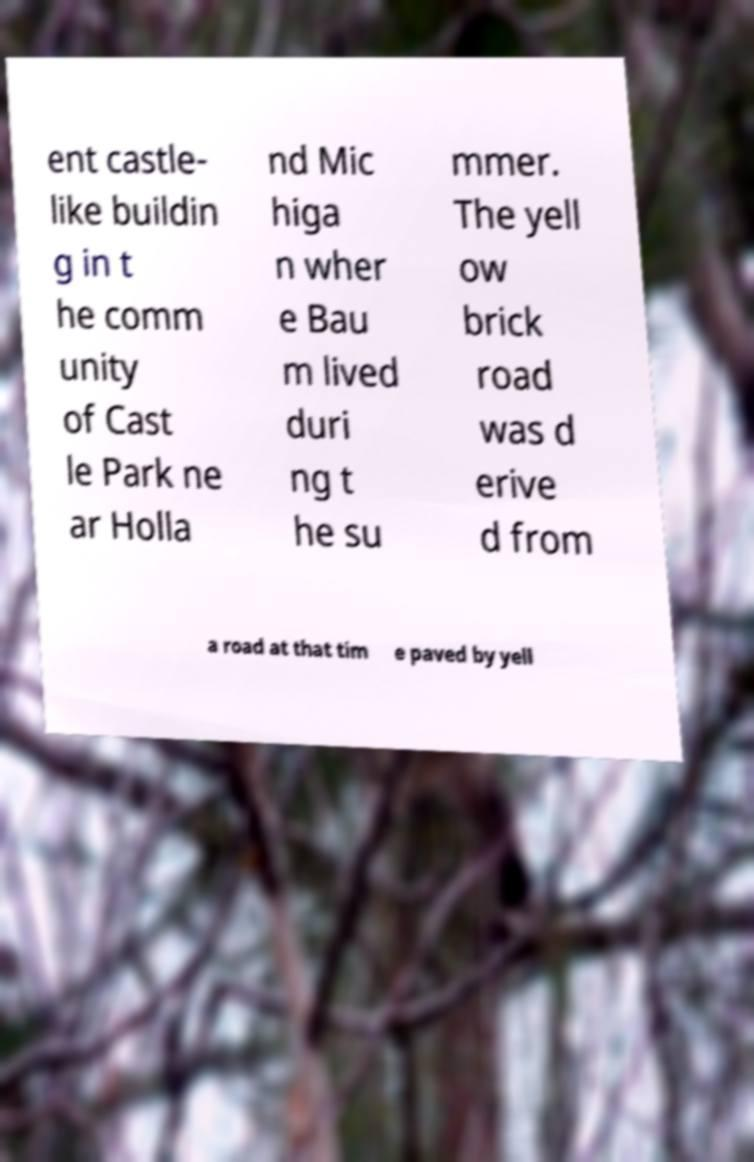Could you assist in decoding the text presented in this image and type it out clearly? ent castle- like buildin g in t he comm unity of Cast le Park ne ar Holla nd Mic higa n wher e Bau m lived duri ng t he su mmer. The yell ow brick road was d erive d from a road at that tim e paved by yell 